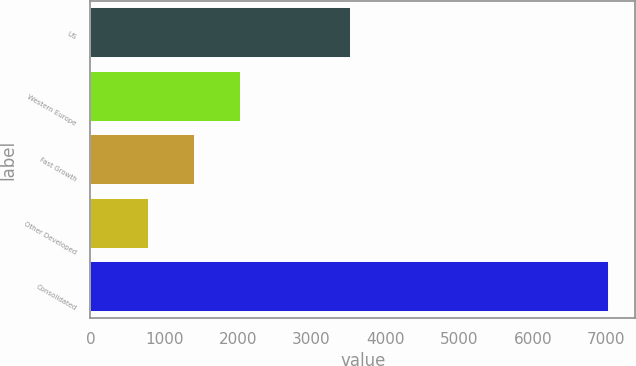<chart> <loc_0><loc_0><loc_500><loc_500><bar_chart><fcel>US<fcel>Western Europe<fcel>Fast Growth<fcel>Other Developed<fcel>Consolidated<nl><fcel>3541.1<fcel>2046.52<fcel>1422.46<fcel>798.4<fcel>7039<nl></chart> 